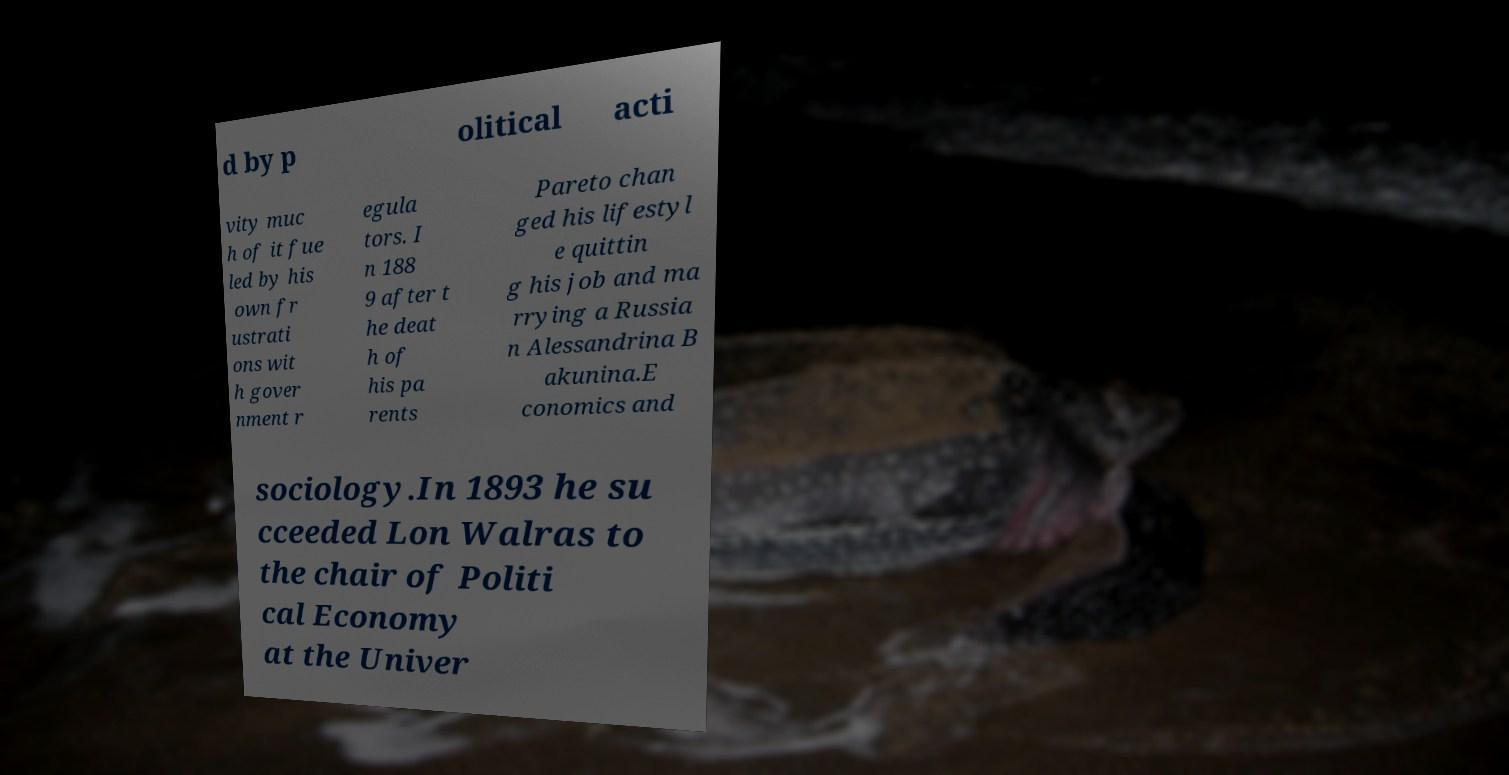Can you read and provide the text displayed in the image?This photo seems to have some interesting text. Can you extract and type it out for me? d by p olitical acti vity muc h of it fue led by his own fr ustrati ons wit h gover nment r egula tors. I n 188 9 after t he deat h of his pa rents Pareto chan ged his lifestyl e quittin g his job and ma rrying a Russia n Alessandrina B akunina.E conomics and sociology.In 1893 he su cceeded Lon Walras to the chair of Politi cal Economy at the Univer 